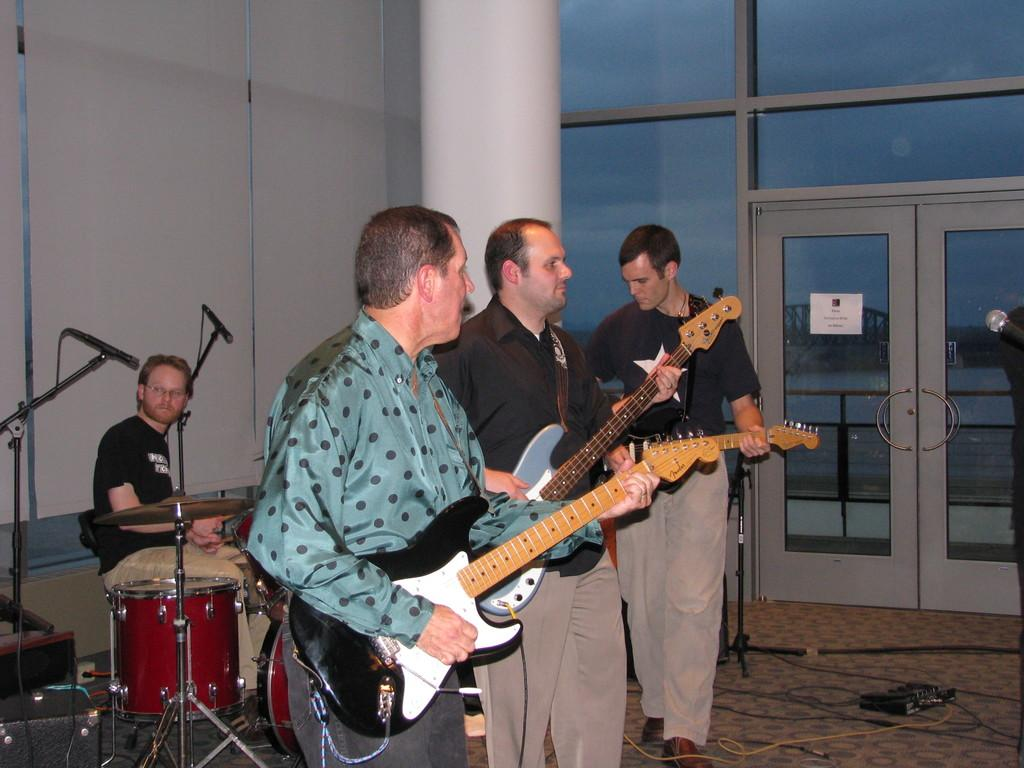How many people are in the room in the image? There are four members in the room. What are the standing members doing in the image? The standing members are playing musical instruments. What can be seen in the background of the image? There is a pillar and a door in the background. How many cats are playing with the musical instruments in the image? There are no cats present in the image; the standing members are playing the musical instruments themselves. What type of activity is the apparatus used for in the image? There is no apparatus present in the image; the focus is on the people playing musical instruments. 